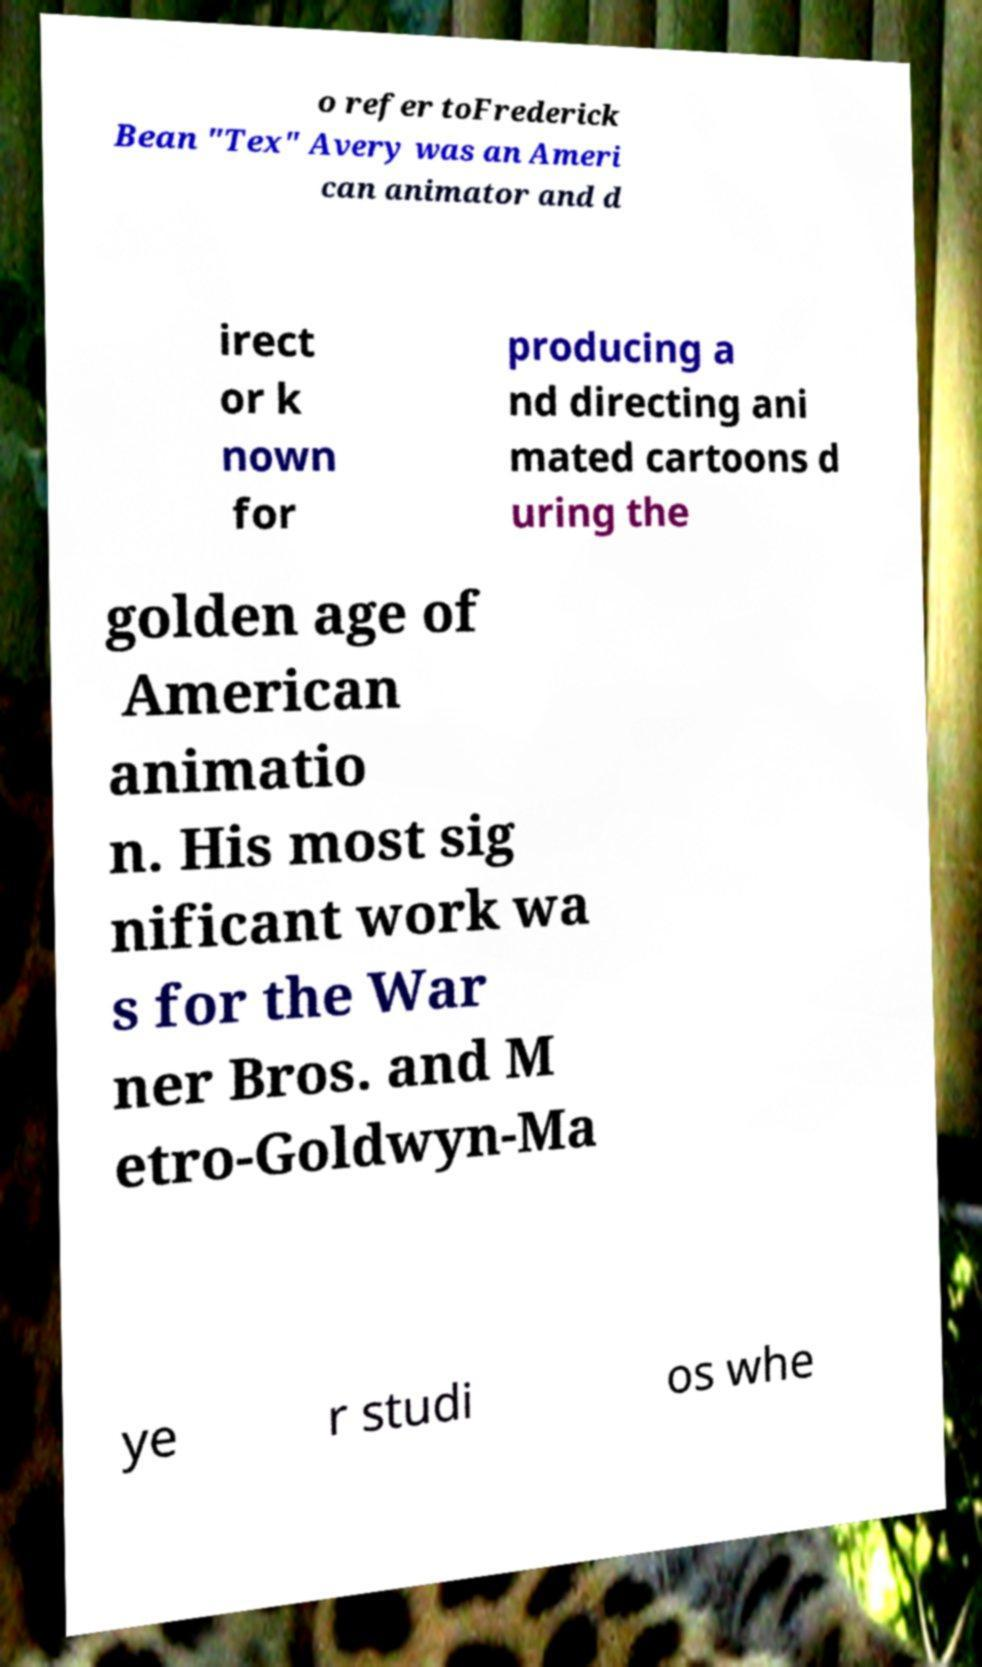Please identify and transcribe the text found in this image. o refer toFrederick Bean "Tex" Avery was an Ameri can animator and d irect or k nown for producing a nd directing ani mated cartoons d uring the golden age of American animatio n. His most sig nificant work wa s for the War ner Bros. and M etro-Goldwyn-Ma ye r studi os whe 